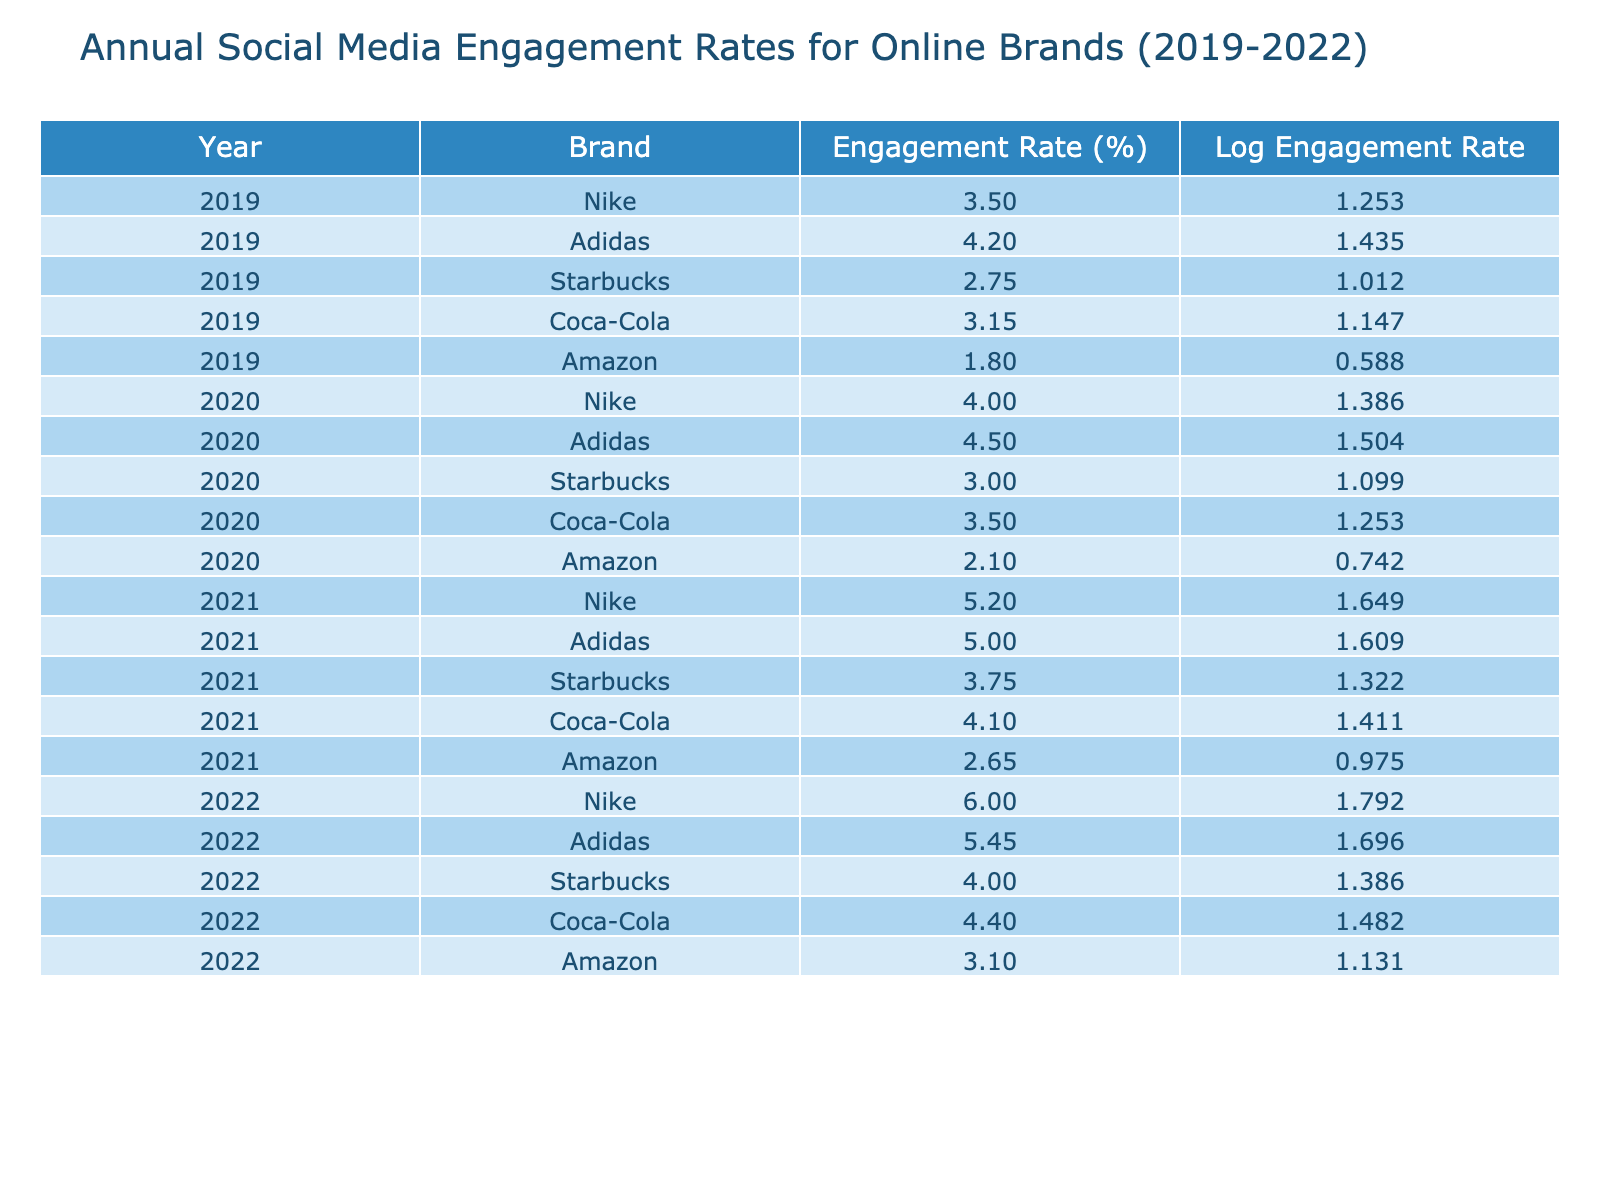What was the highest engagement rate for Nike from 2019 to 2022? The engagement rate for Nike in each year is 3.50 in 2019, 4.00 in 2020, 5.20 in 2021, and 6.00 in 2022. The highest among these is 6.00 in 2022.
Answer: 6.00 Which brand had the lowest engagement rate in 2019? By looking at the engagement rates for 2019, Nike had 3.50, Adidas had 4.20, Starbucks had 2.75, Coca-Cola had 3.15, and Amazon had 1.80. Amazon had the lowest engagement rate with 1.80.
Answer: 1.80 What was the average engagement rate for Adidas from 2019 to 2022? The engagement rates for Adidas over the years are: 4.20 in 2019, 4.50 in 2020, 5.00 in 2021, and 5.45 in 2022. Adding these gives 4.20 + 4.50 + 5.00 + 5.45 = 19.15. Dividing by 4 (the number of years), the average is 19.15 / 4 = 4.79.
Answer: 4.79 Did Starbucks experience an increase in engagement rate every year from 2019 to 2022? The engagement rates for Starbucks are 2.75 in 2019, 3.00 in 2020, 3.75 in 2021, and 4.00 in 2022. Since each year’s rate is higher than the previous year’s, Starbucks did experience an increase in engagement rate every year.
Answer: Yes What is the total engagement rate for Amazon from 2019 to 2022? The engagement rates for Amazon are 1.80 in 2019, 2.10 in 2020, 2.65 in 2021, and 3.10 in 2022. Adding these gives 1.80 + 2.10 + 2.65 + 3.10 = 9.65.
Answer: 9.65 Which brand showed the largest increase in engagement rate from 2019 to 2022? To find the largest increase, we calculate the difference in engagement rates for each brand. Nike increased from 3.50 to 6.00 (2.50 increase), Adidas from 4.20 to 5.45 (1.25 increase), Starbucks from 2.75 to 4.00 (1.25 increase), Coca-Cola from 3.15 to 4.40 (1.25 increase), and Amazon from 1.80 to 3.10 (1.30 increase). Thus, Nike had the largest increase of 2.50.
Answer: Nike What was the logarithmic value of the engagement rate for Coca-Cola in 2022? The engagement rate for Coca-Cola in 2022 is 4.40. Taking the natural logarithm (ln) of this gives approximately 1.4816. This can be derived from the logarithmic transformation of the engagement rate.
Answer: 1.4816 Was there any year where Adidas had a lower engagement rate than Coca-Cola? In 2019, Adidas had 4.20 while Coca-Cola had 3.15. In 2020, Adidas had 4.50 versus Coca-Cola's 3.50. In 2021, Adidas was at 5.00, and Coca-Cola at 4.10. However, in 2022, Adidas had 5.45 while Coca-Cola was 4.40. All years show Adidas having a higher engagement rate than Coca-Cola.
Answer: No 